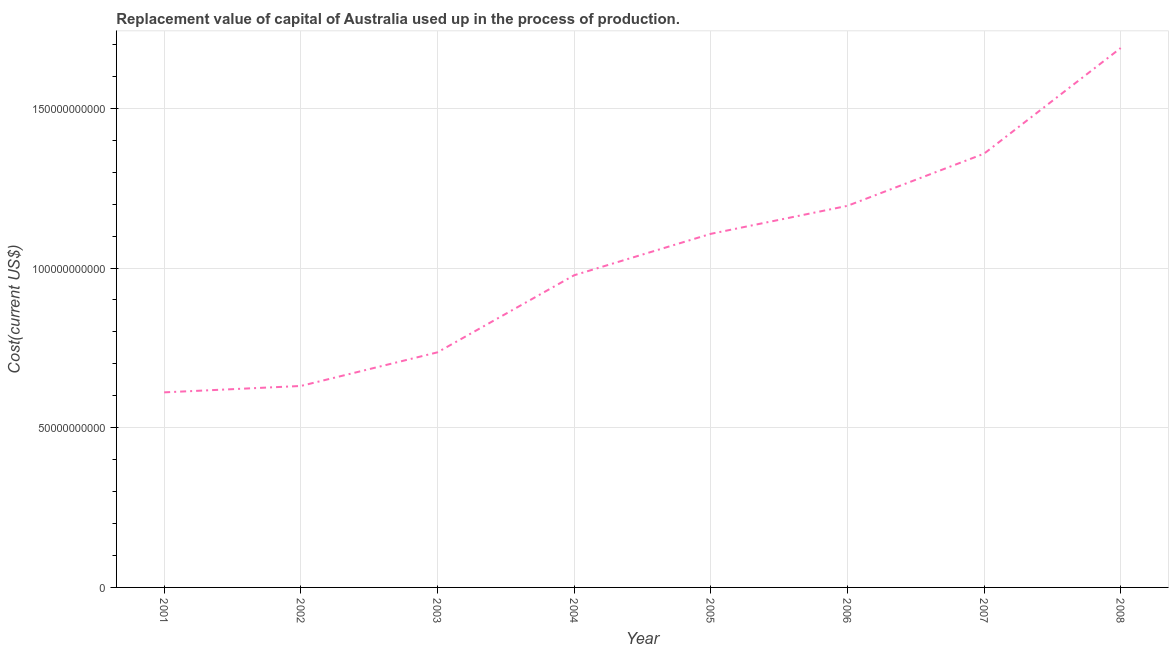What is the consumption of fixed capital in 2006?
Provide a succinct answer. 1.19e+11. Across all years, what is the maximum consumption of fixed capital?
Make the answer very short. 1.69e+11. Across all years, what is the minimum consumption of fixed capital?
Make the answer very short. 6.11e+1. What is the sum of the consumption of fixed capital?
Keep it short and to the point. 8.30e+11. What is the difference between the consumption of fixed capital in 2001 and 2008?
Make the answer very short. -1.08e+11. What is the average consumption of fixed capital per year?
Keep it short and to the point. 1.04e+11. What is the median consumption of fixed capital?
Ensure brevity in your answer.  1.04e+11. What is the ratio of the consumption of fixed capital in 2003 to that in 2004?
Keep it short and to the point. 0.75. Is the consumption of fixed capital in 2004 less than that in 2005?
Offer a very short reply. Yes. What is the difference between the highest and the second highest consumption of fixed capital?
Ensure brevity in your answer.  3.31e+1. What is the difference between the highest and the lowest consumption of fixed capital?
Provide a succinct answer. 1.08e+11. How many lines are there?
Provide a short and direct response. 1. How many years are there in the graph?
Make the answer very short. 8. What is the difference between two consecutive major ticks on the Y-axis?
Provide a succinct answer. 5.00e+1. What is the title of the graph?
Make the answer very short. Replacement value of capital of Australia used up in the process of production. What is the label or title of the X-axis?
Ensure brevity in your answer.  Year. What is the label or title of the Y-axis?
Your answer should be compact. Cost(current US$). What is the Cost(current US$) in 2001?
Provide a short and direct response. 6.11e+1. What is the Cost(current US$) of 2002?
Your answer should be compact. 6.31e+1. What is the Cost(current US$) of 2003?
Provide a short and direct response. 7.36e+1. What is the Cost(current US$) in 2004?
Ensure brevity in your answer.  9.77e+1. What is the Cost(current US$) of 2005?
Your answer should be very brief. 1.11e+11. What is the Cost(current US$) of 2006?
Keep it short and to the point. 1.19e+11. What is the Cost(current US$) in 2007?
Keep it short and to the point. 1.36e+11. What is the Cost(current US$) of 2008?
Provide a short and direct response. 1.69e+11. What is the difference between the Cost(current US$) in 2001 and 2002?
Give a very brief answer. -2.00e+09. What is the difference between the Cost(current US$) in 2001 and 2003?
Give a very brief answer. -1.25e+1. What is the difference between the Cost(current US$) in 2001 and 2004?
Keep it short and to the point. -3.67e+1. What is the difference between the Cost(current US$) in 2001 and 2005?
Ensure brevity in your answer.  -4.96e+1. What is the difference between the Cost(current US$) in 2001 and 2006?
Keep it short and to the point. -5.84e+1. What is the difference between the Cost(current US$) in 2001 and 2007?
Make the answer very short. -7.47e+1. What is the difference between the Cost(current US$) in 2001 and 2008?
Keep it short and to the point. -1.08e+11. What is the difference between the Cost(current US$) in 2002 and 2003?
Offer a terse response. -1.05e+1. What is the difference between the Cost(current US$) in 2002 and 2004?
Your answer should be very brief. -3.47e+1. What is the difference between the Cost(current US$) in 2002 and 2005?
Your response must be concise. -4.76e+1. What is the difference between the Cost(current US$) in 2002 and 2006?
Keep it short and to the point. -5.64e+1. What is the difference between the Cost(current US$) in 2002 and 2007?
Your answer should be very brief. -7.27e+1. What is the difference between the Cost(current US$) in 2002 and 2008?
Provide a short and direct response. -1.06e+11. What is the difference between the Cost(current US$) in 2003 and 2004?
Give a very brief answer. -2.41e+1. What is the difference between the Cost(current US$) in 2003 and 2005?
Your answer should be compact. -3.71e+1. What is the difference between the Cost(current US$) in 2003 and 2006?
Give a very brief answer. -4.59e+1. What is the difference between the Cost(current US$) in 2003 and 2007?
Provide a short and direct response. -6.22e+1. What is the difference between the Cost(current US$) in 2003 and 2008?
Make the answer very short. -9.53e+1. What is the difference between the Cost(current US$) in 2004 and 2005?
Your answer should be compact. -1.30e+1. What is the difference between the Cost(current US$) in 2004 and 2006?
Your response must be concise. -2.17e+1. What is the difference between the Cost(current US$) in 2004 and 2007?
Ensure brevity in your answer.  -3.81e+1. What is the difference between the Cost(current US$) in 2004 and 2008?
Provide a succinct answer. -7.11e+1. What is the difference between the Cost(current US$) in 2005 and 2006?
Your answer should be compact. -8.77e+09. What is the difference between the Cost(current US$) in 2005 and 2007?
Your answer should be compact. -2.51e+1. What is the difference between the Cost(current US$) in 2005 and 2008?
Offer a terse response. -5.82e+1. What is the difference between the Cost(current US$) in 2006 and 2007?
Provide a short and direct response. -1.63e+1. What is the difference between the Cost(current US$) in 2006 and 2008?
Provide a short and direct response. -4.94e+1. What is the difference between the Cost(current US$) in 2007 and 2008?
Your response must be concise. -3.31e+1. What is the ratio of the Cost(current US$) in 2001 to that in 2003?
Provide a succinct answer. 0.83. What is the ratio of the Cost(current US$) in 2001 to that in 2005?
Offer a very short reply. 0.55. What is the ratio of the Cost(current US$) in 2001 to that in 2006?
Give a very brief answer. 0.51. What is the ratio of the Cost(current US$) in 2001 to that in 2007?
Your answer should be compact. 0.45. What is the ratio of the Cost(current US$) in 2001 to that in 2008?
Offer a very short reply. 0.36. What is the ratio of the Cost(current US$) in 2002 to that in 2003?
Your answer should be compact. 0.86. What is the ratio of the Cost(current US$) in 2002 to that in 2004?
Make the answer very short. 0.65. What is the ratio of the Cost(current US$) in 2002 to that in 2005?
Ensure brevity in your answer.  0.57. What is the ratio of the Cost(current US$) in 2002 to that in 2006?
Ensure brevity in your answer.  0.53. What is the ratio of the Cost(current US$) in 2002 to that in 2007?
Provide a short and direct response. 0.46. What is the ratio of the Cost(current US$) in 2002 to that in 2008?
Your answer should be very brief. 0.37. What is the ratio of the Cost(current US$) in 2003 to that in 2004?
Your answer should be very brief. 0.75. What is the ratio of the Cost(current US$) in 2003 to that in 2005?
Keep it short and to the point. 0.67. What is the ratio of the Cost(current US$) in 2003 to that in 2006?
Your answer should be very brief. 0.62. What is the ratio of the Cost(current US$) in 2003 to that in 2007?
Make the answer very short. 0.54. What is the ratio of the Cost(current US$) in 2003 to that in 2008?
Offer a terse response. 0.44. What is the ratio of the Cost(current US$) in 2004 to that in 2005?
Keep it short and to the point. 0.88. What is the ratio of the Cost(current US$) in 2004 to that in 2006?
Offer a very short reply. 0.82. What is the ratio of the Cost(current US$) in 2004 to that in 2007?
Make the answer very short. 0.72. What is the ratio of the Cost(current US$) in 2004 to that in 2008?
Keep it short and to the point. 0.58. What is the ratio of the Cost(current US$) in 2005 to that in 2006?
Keep it short and to the point. 0.93. What is the ratio of the Cost(current US$) in 2005 to that in 2007?
Make the answer very short. 0.81. What is the ratio of the Cost(current US$) in 2005 to that in 2008?
Your answer should be compact. 0.66. What is the ratio of the Cost(current US$) in 2006 to that in 2008?
Offer a very short reply. 0.71. What is the ratio of the Cost(current US$) in 2007 to that in 2008?
Your answer should be compact. 0.8. 